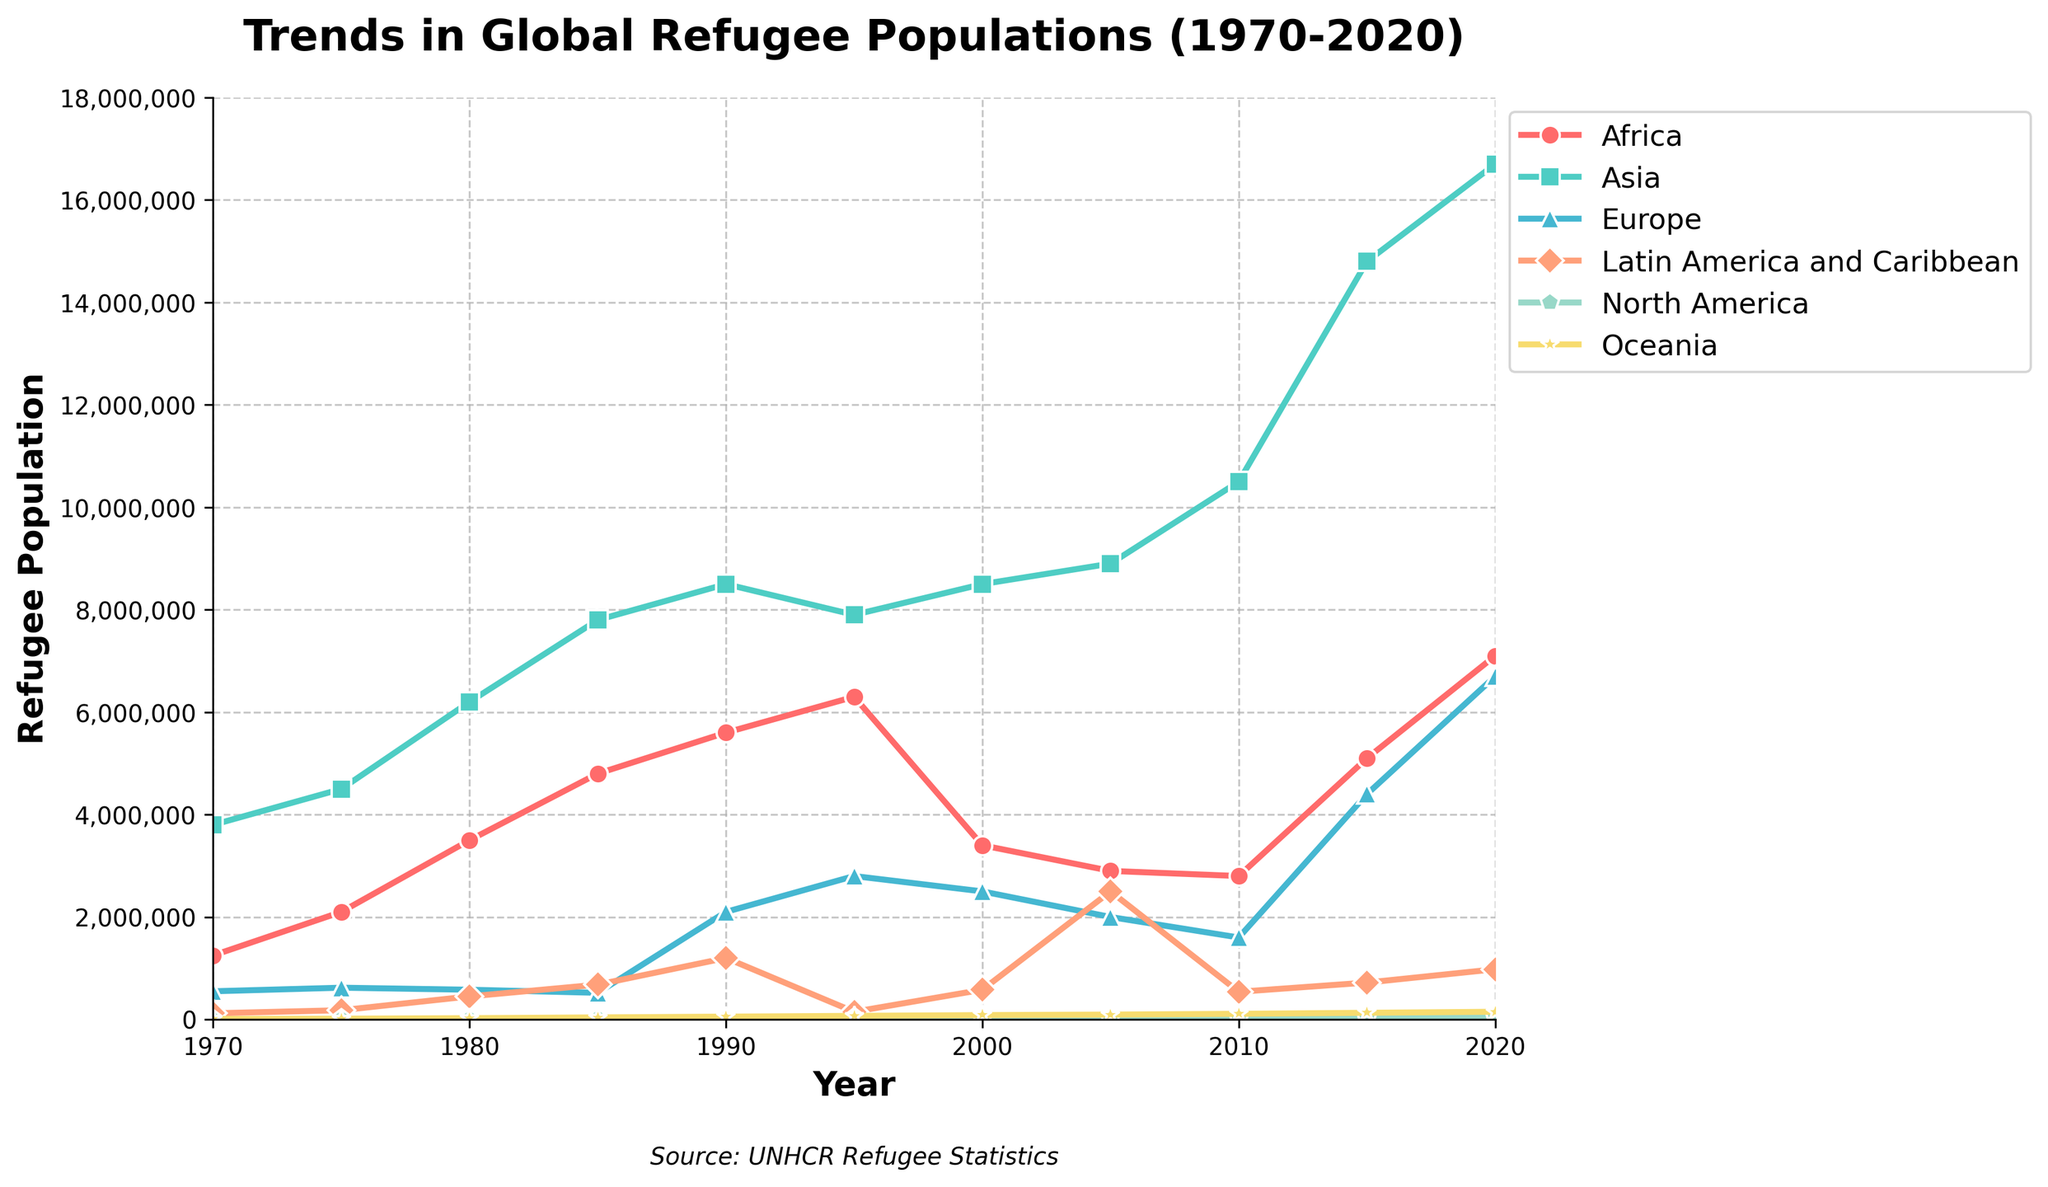What's the highest refugee population recorded in the Asia region, and in which year? Looking at the trend for the Asia region, the peak value appears around the 2020 mark. The exact highest value needs to be examined from the visual data points.
Answer: 16,700,000 in 2020 Which region had a larger refugee population in 1990, Africa or Europe? Compare the data points for Africa and Europe in 1990. The visual shows Africa's line at a lower point than Europe's.
Answer: Europe What was the total refugee population for the Latin America and Caribbean (2015) and North America (2020) combined? Add the visual values for Latin America and Caribbean in 2015 and North America in 2020.
Answer: 720,000 + 55,000 = 775,000 Which region saw the biggest increase in refugee population from 1970 to 2020? Observe the difference by comparing the starting and ending points for each line. The steepest rise should indicate the largest increase.
Answer: Asia By how much did the refugee population in Oceania increase from 1970 to 2020? Subtract the 1970 value from the 2020 value for the Oceania line.
Answer: 150,000 - 10,000 = 140,000 Which region displayed a decline in refugee population between 1995 and 2000? Compare the plot lines' slopes for each category from 1995 to 2000. A downward slope indicates a decrease.
Answer: Africa In what year did the refugee population in Europe exceed 4 million? Look for the first visual data point where Europe's trend crosses 4 million.
Answer: 2015 Compare the refugee population of Africa and Latin America and Caribbean in 2010. Which region had fewer refugees? Check the data points for both regions in the year 2010. Africa's line lies higher than Latin America and Caribbean's.
Answer: Latin America and Caribbean What trend can be observed for North America's refugee population over the 50 year period? Observe the slope and direction of the North America line from start to finish. It shows a generally increasing trend.
Answer: Increasing How much did the refugee population in Asia increase between 2005 and 2015, and what might this indicate? Subtract the value in 2005 from the value in 2015 for Asia. This would indicate the increase.
Answer: 14,800,000 - 8,900,000 = 5,900,000 